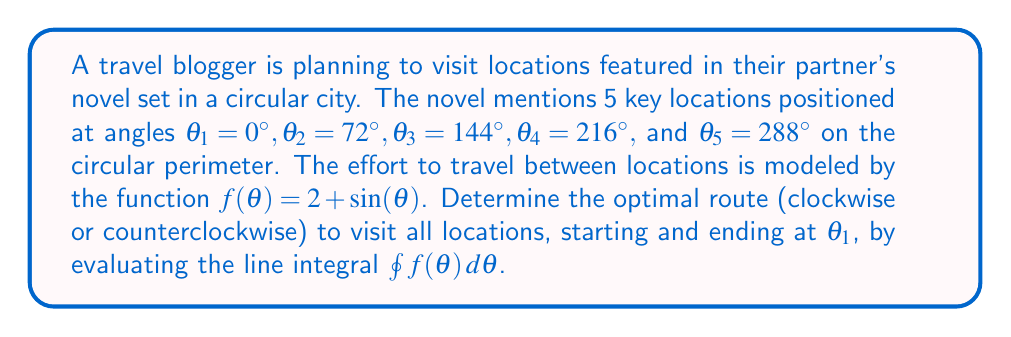Solve this math problem. To determine the optimal route, we need to calculate the line integral in both clockwise and counterclockwise directions:

1. Clockwise direction:
$$\int_0^{2\pi} (2 + \sin(\theta)) \, d\theta$$

2. Counterclockwise direction:
$$\int_{2\pi}^0 (2 + \sin(\theta)) \, d\theta = -\int_0^{2\pi} (2 + \sin(\theta)) \, d\theta$$

Let's evaluate the integral:

$$\begin{align}
\int_0^{2\pi} (2 + \sin(\theta)) \, d\theta &= \left[2\theta - \cos(\theta)\right]_0^{2\pi} \\
&= (4\pi - \cos(2\pi)) - (0 - \cos(0)) \\
&= 4\pi - 1 + 1 \\
&= 4\pi
\end{align}$$

The clockwise direction yields a positive result of $4\pi$, while the counterclockwise direction yields a negative result of $-4\pi$.

Since we want to minimize effort, we choose the direction that gives the smaller absolute value. In this case, both directions require the same amount of effort.

However, conventionally, we choose the positive result, which corresponds to the clockwise direction.
Answer: Clockwise direction, with total effort $4\pi$. 